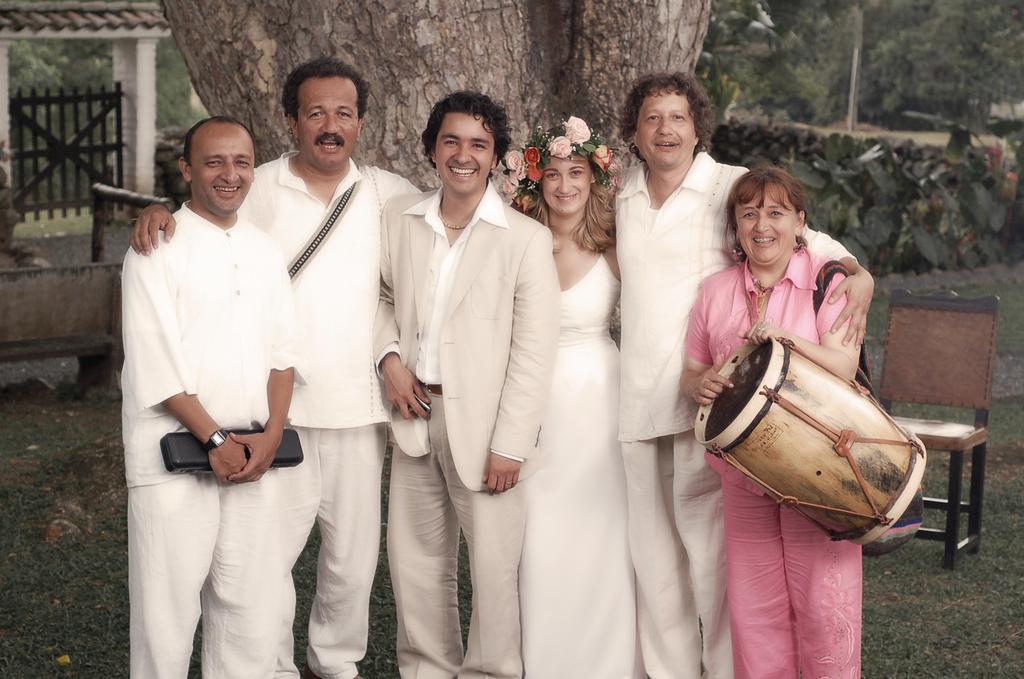Can you describe this image briefly? There are four men and two women standing and smiling. Women at the right side of the image is holding a drum and women at the middle is wearing a beautiful flower crown. At background I can see a big tree trunk. This is a gate which is black in color,and these are small plants and trees. This is a chair. 